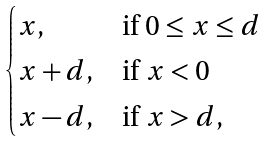Convert formula to latex. <formula><loc_0><loc_0><loc_500><loc_500>\begin{cases} x , & \text {if $0\leq x\leq d$} \\ x + d , & \text {if $x<0$} \\ x - d , & \text {if $x>d$} , \end{cases}</formula> 